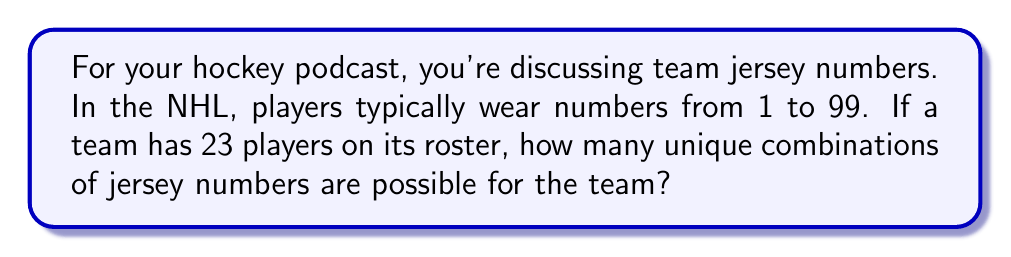Provide a solution to this math problem. Let's approach this step-by-step:

1) This is a combination problem. We're selecting 23 numbers out of 99 possible numbers, where the order doesn't matter (it doesn't matter which player wears which number, just which numbers are used).

2) The formula for combinations is:

   $$C(n,r) = \frac{n!}{r!(n-r)!}$$

   Where $n$ is the total number of items to choose from, and $r$ is the number of items being chosen.

3) In this case, $n = 99$ (total possible numbers) and $r = 23$ (roster size).

4) Substituting these values into our formula:

   $$C(99,23) = \frac{99!}{23!(99-23)!} = \frac{99!}{23!76!}$$

5) This can be calculated as:

   $$\frac{99 \times 98 \times 97 \times ... \times 78 \times 77}{23 \times 22 \times 21 \times ... \times 2 \times 1}$$

6) Using a calculator or computer (as this number is too large for manual calculation), we get:

   $$C(99,23) = 90,572,001,949,537,500$$

This enormous number represents all possible unique combinations of 23 jersey numbers chosen from the numbers 1 to 99.
Answer: $90,572,001,949,537,500$ 